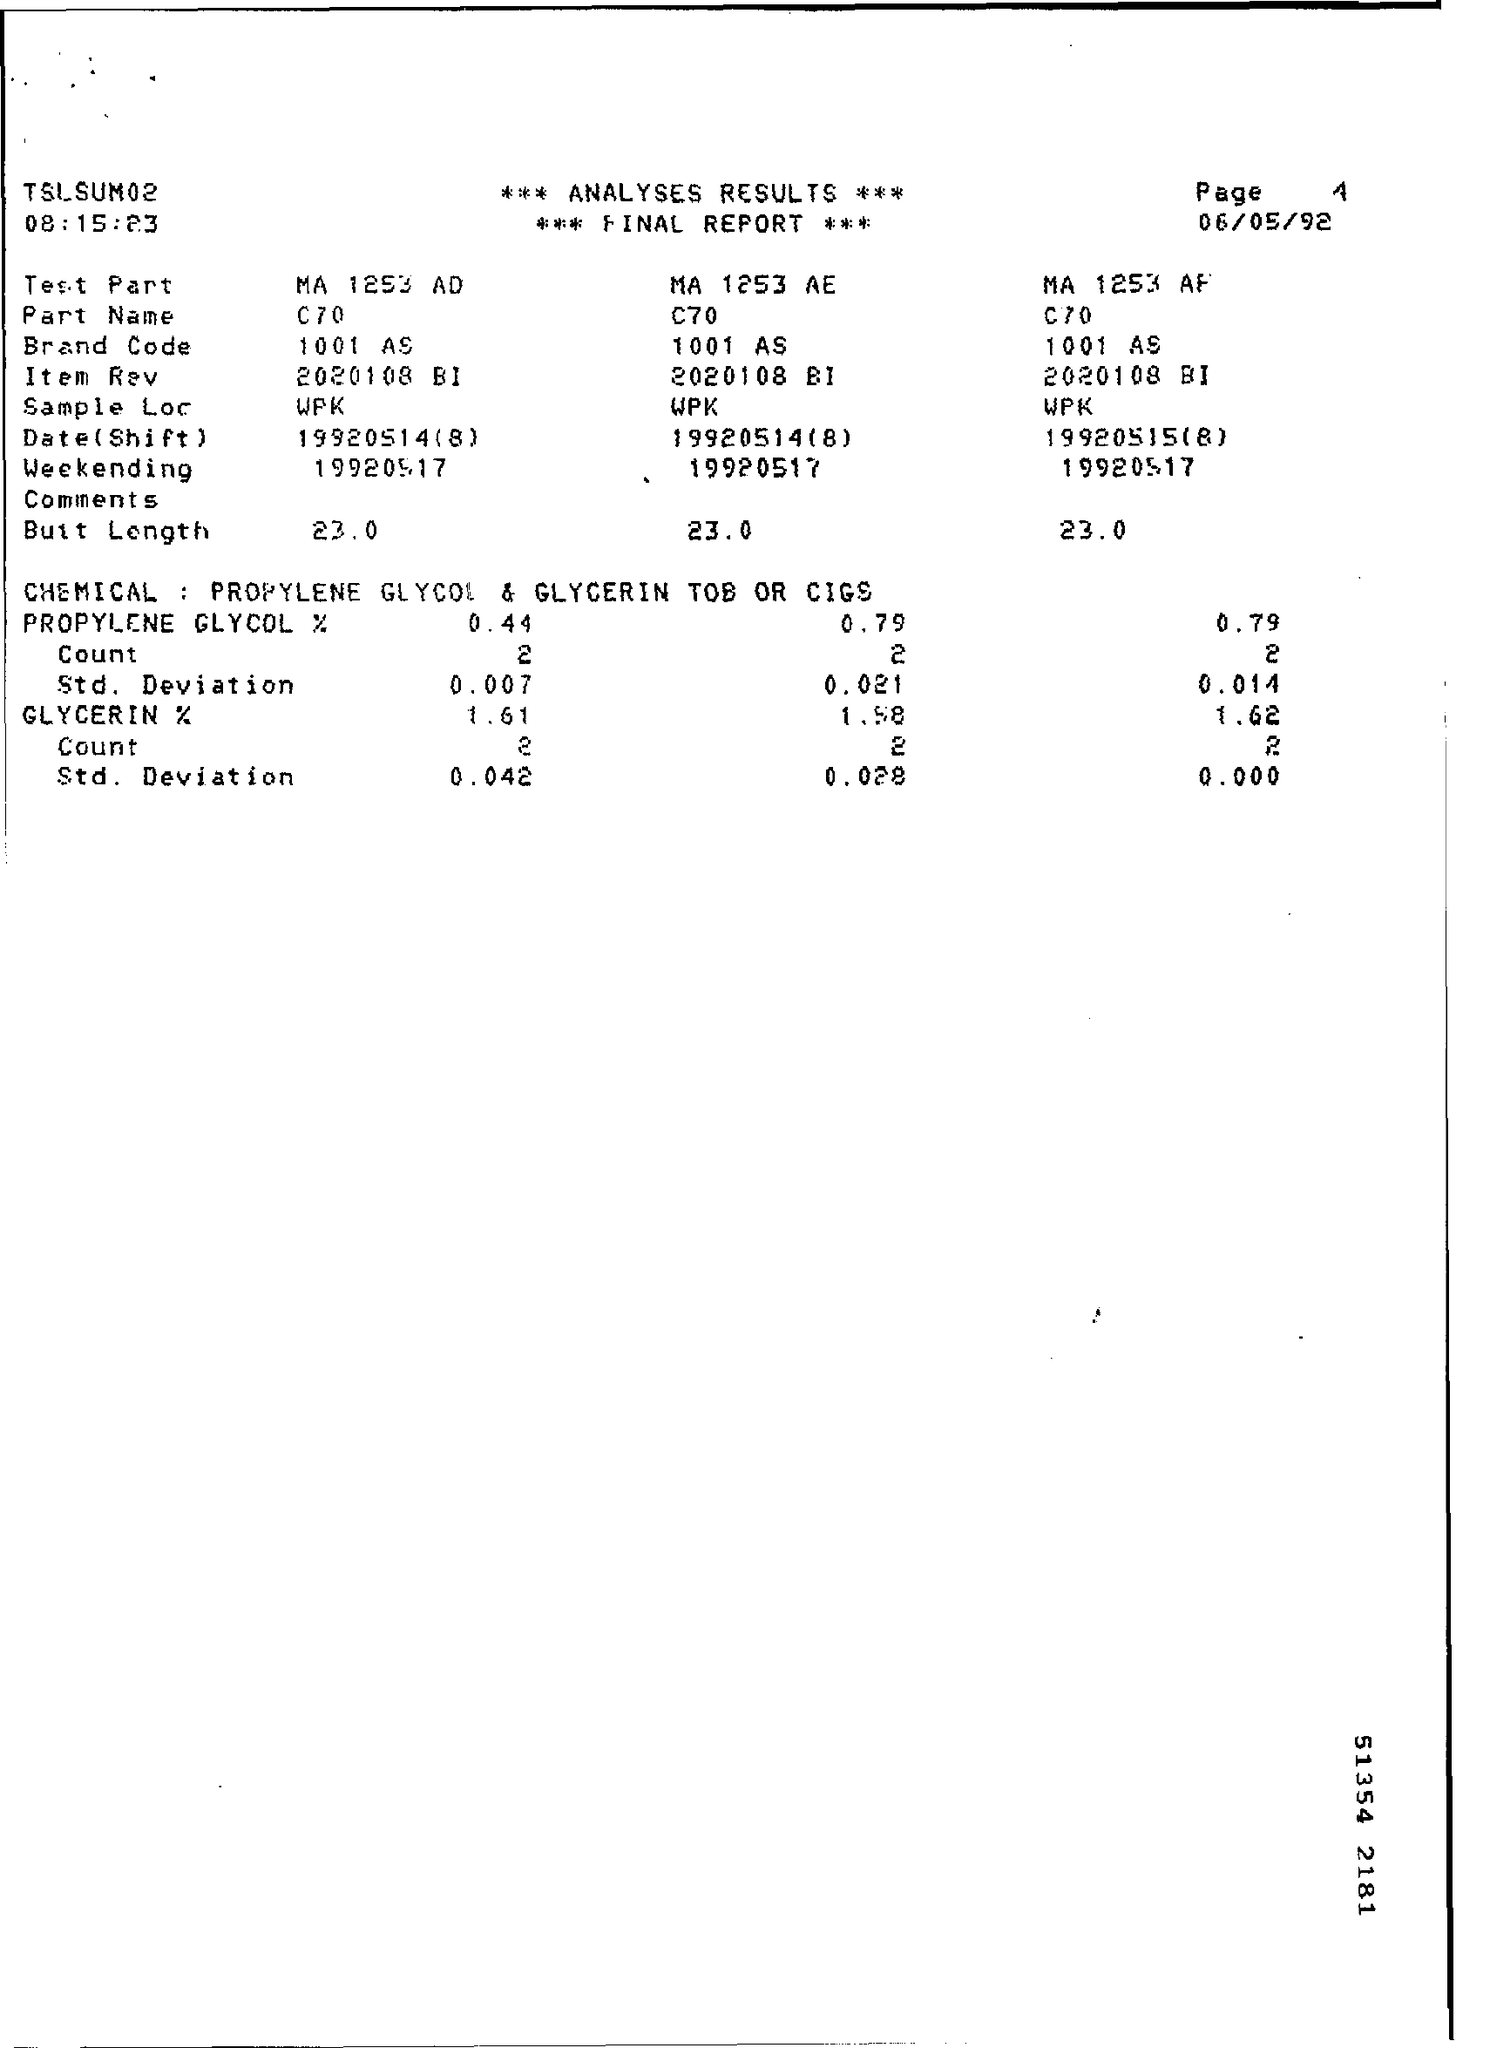Highlight a few significant elements in this photo. The brand code for the test part with the identifier MA 1253 AD is 1001 AS. The brand code for the test part with the identifier MA 1253 AE is 1001 AS. What is the date for the test part MA1253 AD, specifically 19920514(8)? The time mentioned is 08:15:23. The date mentioned is 06/05/92. 